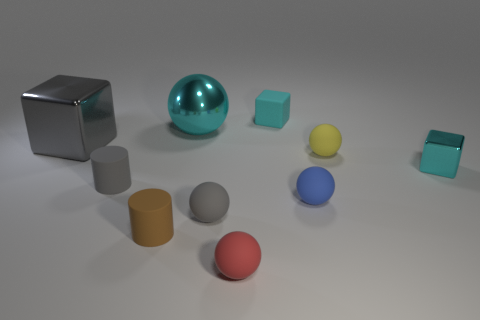How many balls have the same size as the red thing?
Your response must be concise. 3. What number of other things are there of the same color as the small shiny block?
Your answer should be very brief. 2. Is the shape of the small gray matte thing in front of the gray rubber cylinder the same as the small cyan thing behind the small cyan metal block?
Offer a terse response. No. What shape is the cyan object that is the same size as the gray block?
Keep it short and to the point. Sphere. Is the number of small blue balls that are on the right side of the small yellow rubber ball the same as the number of large shiny objects on the left side of the brown rubber cylinder?
Your answer should be very brief. No. Is the block behind the big cyan object made of the same material as the tiny blue thing?
Keep it short and to the point. Yes. There is a cyan sphere that is the same size as the gray block; what is its material?
Your answer should be compact. Metal. How many other objects are there of the same material as the small gray cylinder?
Your answer should be compact. 6. Does the cyan rubber thing have the same size as the shiny cube in front of the yellow matte thing?
Keep it short and to the point. Yes. Is the number of large cyan metallic things in front of the cyan sphere less than the number of balls that are on the right side of the red rubber object?
Ensure brevity in your answer.  Yes. 